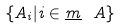Convert formula to latex. <formula><loc_0><loc_0><loc_500><loc_500>\{ A _ { i } | i \in \underline { m } \ A \}</formula> 